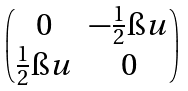<formula> <loc_0><loc_0><loc_500><loc_500>\begin{pmatrix} 0 & - \frac { 1 } { 2 } \i u \\ \frac { 1 } { 2 } \i u & 0 \end{pmatrix}</formula> 